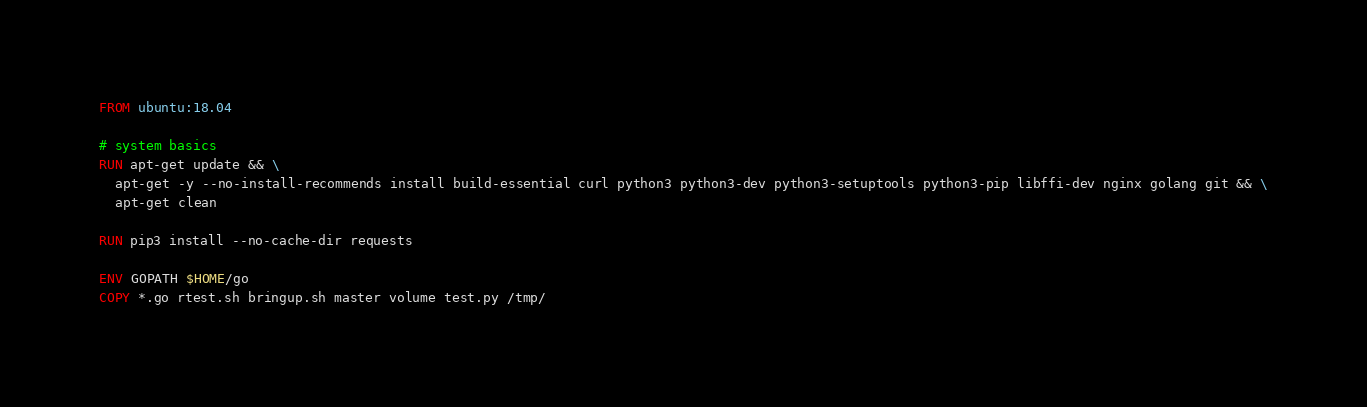Convert code to text. <code><loc_0><loc_0><loc_500><loc_500><_Dockerfile_>FROM ubuntu:18.04

# system basics
RUN apt-get update && \
  apt-get -y --no-install-recommends install build-essential curl python3 python3-dev python3-setuptools python3-pip libffi-dev nginx golang git && \
  apt-get clean

RUN pip3 install --no-cache-dir requests

ENV GOPATH $HOME/go  
COPY *.go rtest.sh bringup.sh master volume test.py /tmp/
</code> 